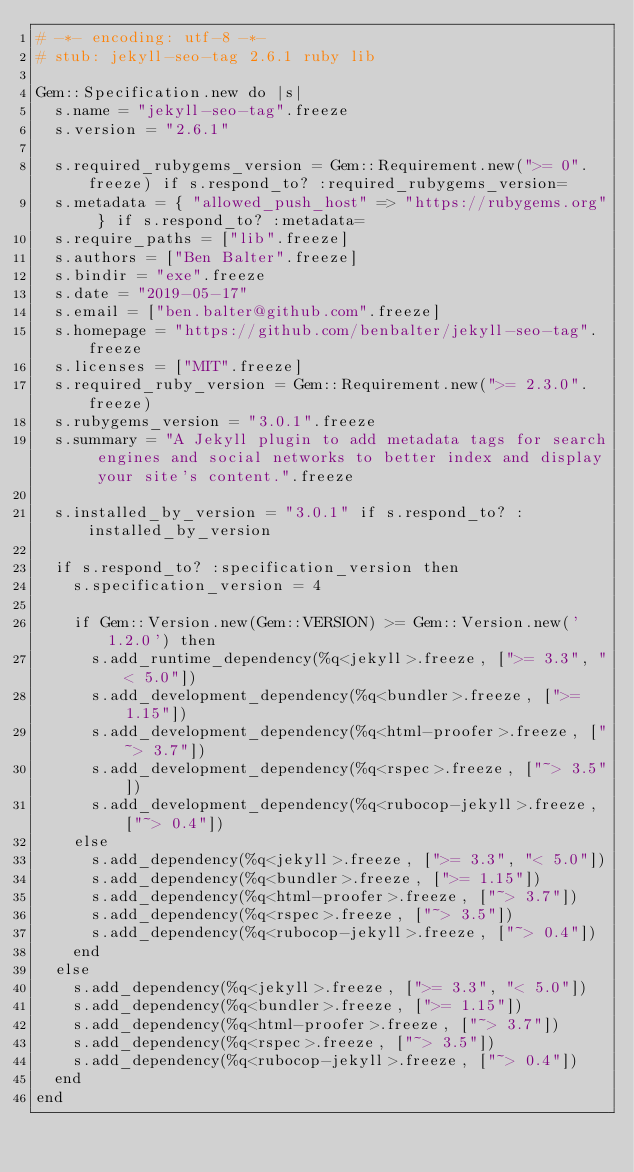<code> <loc_0><loc_0><loc_500><loc_500><_Ruby_># -*- encoding: utf-8 -*-
# stub: jekyll-seo-tag 2.6.1 ruby lib

Gem::Specification.new do |s|
  s.name = "jekyll-seo-tag".freeze
  s.version = "2.6.1"

  s.required_rubygems_version = Gem::Requirement.new(">= 0".freeze) if s.respond_to? :required_rubygems_version=
  s.metadata = { "allowed_push_host" => "https://rubygems.org" } if s.respond_to? :metadata=
  s.require_paths = ["lib".freeze]
  s.authors = ["Ben Balter".freeze]
  s.bindir = "exe".freeze
  s.date = "2019-05-17"
  s.email = ["ben.balter@github.com".freeze]
  s.homepage = "https://github.com/benbalter/jekyll-seo-tag".freeze
  s.licenses = ["MIT".freeze]
  s.required_ruby_version = Gem::Requirement.new(">= 2.3.0".freeze)
  s.rubygems_version = "3.0.1".freeze
  s.summary = "A Jekyll plugin to add metadata tags for search engines and social networks to better index and display your site's content.".freeze

  s.installed_by_version = "3.0.1" if s.respond_to? :installed_by_version

  if s.respond_to? :specification_version then
    s.specification_version = 4

    if Gem::Version.new(Gem::VERSION) >= Gem::Version.new('1.2.0') then
      s.add_runtime_dependency(%q<jekyll>.freeze, [">= 3.3", "< 5.0"])
      s.add_development_dependency(%q<bundler>.freeze, [">= 1.15"])
      s.add_development_dependency(%q<html-proofer>.freeze, ["~> 3.7"])
      s.add_development_dependency(%q<rspec>.freeze, ["~> 3.5"])
      s.add_development_dependency(%q<rubocop-jekyll>.freeze, ["~> 0.4"])
    else
      s.add_dependency(%q<jekyll>.freeze, [">= 3.3", "< 5.0"])
      s.add_dependency(%q<bundler>.freeze, [">= 1.15"])
      s.add_dependency(%q<html-proofer>.freeze, ["~> 3.7"])
      s.add_dependency(%q<rspec>.freeze, ["~> 3.5"])
      s.add_dependency(%q<rubocop-jekyll>.freeze, ["~> 0.4"])
    end
  else
    s.add_dependency(%q<jekyll>.freeze, [">= 3.3", "< 5.0"])
    s.add_dependency(%q<bundler>.freeze, [">= 1.15"])
    s.add_dependency(%q<html-proofer>.freeze, ["~> 3.7"])
    s.add_dependency(%q<rspec>.freeze, ["~> 3.5"])
    s.add_dependency(%q<rubocop-jekyll>.freeze, ["~> 0.4"])
  end
end
</code> 